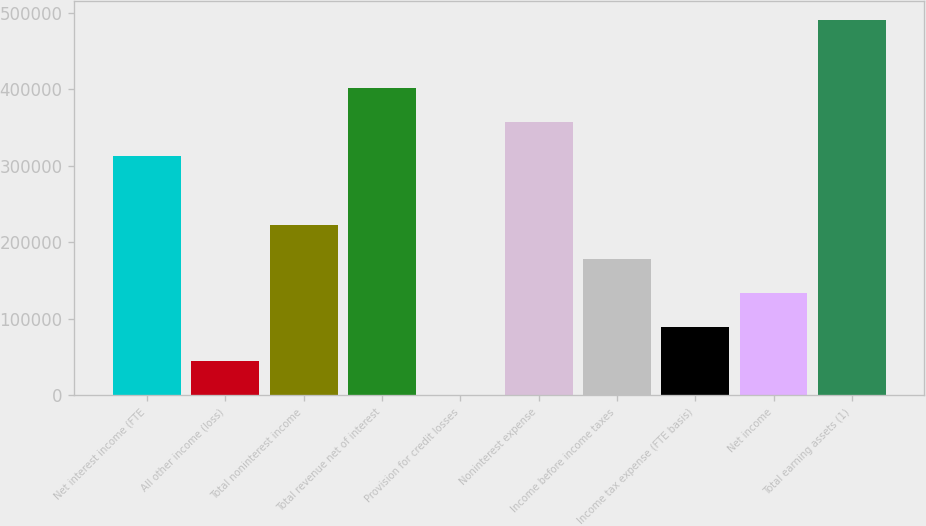Convert chart to OTSL. <chart><loc_0><loc_0><loc_500><loc_500><bar_chart><fcel>Net interest income (FTE<fcel>All other income (loss)<fcel>Total noninterest income<fcel>Total revenue net of interest<fcel>Provision for credit losses<fcel>Noninterest expense<fcel>Income before income taxes<fcel>Income tax expense (FTE basis)<fcel>Net income<fcel>Total earning assets (1)<nl><fcel>312584<fcel>44803.2<fcel>223324<fcel>401845<fcel>173<fcel>357215<fcel>178694<fcel>89433.4<fcel>134064<fcel>491105<nl></chart> 